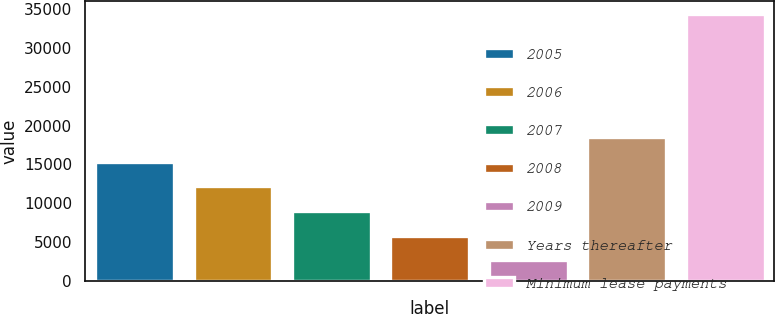Convert chart. <chart><loc_0><loc_0><loc_500><loc_500><bar_chart><fcel>2005<fcel>2006<fcel>2007<fcel>2008<fcel>2009<fcel>Years thereafter<fcel>Minimum lease payments<nl><fcel>15346.4<fcel>12178.8<fcel>9011.2<fcel>5843.6<fcel>2676<fcel>18514<fcel>34352<nl></chart> 